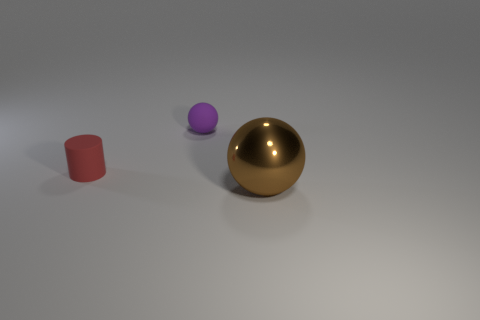Subtract all red balls. Subtract all blue cylinders. How many balls are left? 2 Add 3 large purple metal cylinders. How many objects exist? 6 Subtract all cylinders. How many objects are left? 2 Subtract 0 gray blocks. How many objects are left? 3 Subtract all small balls. Subtract all tiny red things. How many objects are left? 1 Add 3 big brown metallic spheres. How many big brown metallic spheres are left? 4 Add 1 blue matte cylinders. How many blue matte cylinders exist? 1 